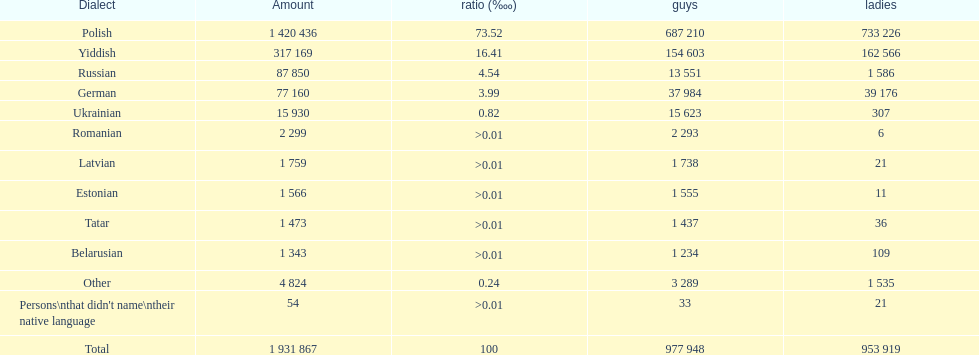Number of male russian speakers 13 551. 